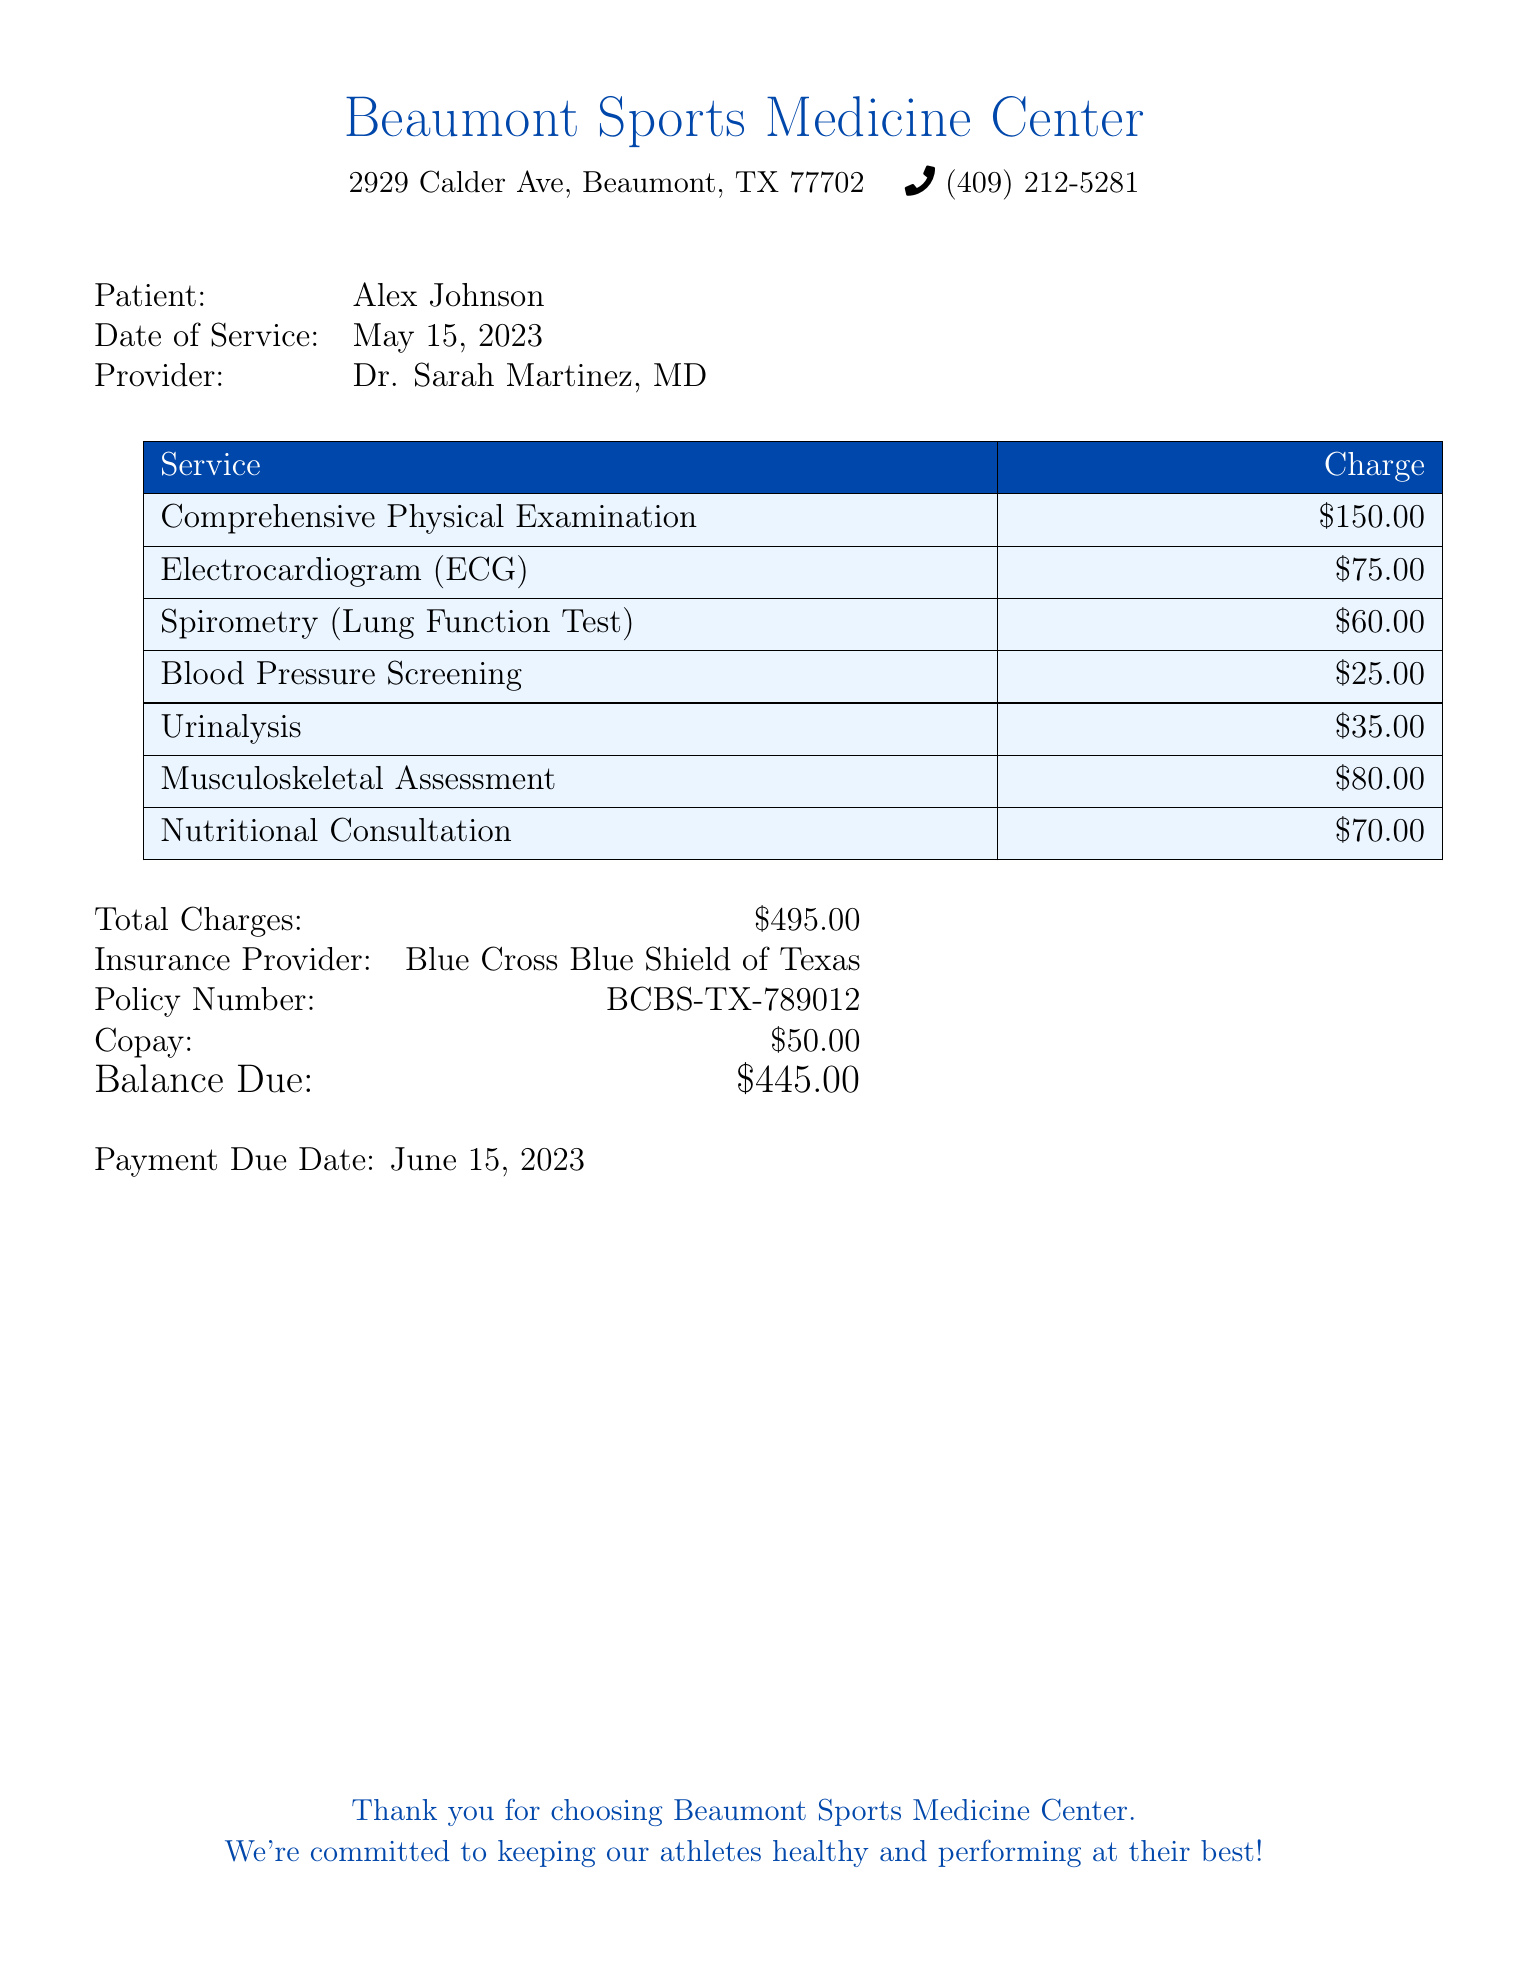What is the patient's name? The patient's name is listed at the top of the document.
Answer: Alex Johnson What is the date of service? The date of service is specified in the document.
Answer: May 15, 2023 Who is the provider? The provider's name is mentioned under patient details.
Answer: Dr. Sarah Martinez, MD What is the charge for the Comprehensive Physical Examination? The charge for that specific service is detailed in the itemized section.
Answer: $150.00 What is the total charge? The total charge is calculated and presented at the end of the itemized list.
Answer: $495.00 What is the balance due after copay? The balance due is listed after deducting the copay from the total charges.
Answer: $445.00 Which insurance provider is indicated on the bill? The insurance provider is mentioned in the details towards the end of the document.
Answer: Blue Cross Blue Shield of Texas How much is the copay? The copay amount is explicitly stated in the document.
Answer: $50.00 What type of test is the ECG? The ECG is listed under the services section of the bill.
Answer: Electrocardiogram What is the payment due date? The payment due date is provided at the bottom of the bill.
Answer: June 15, 2023 